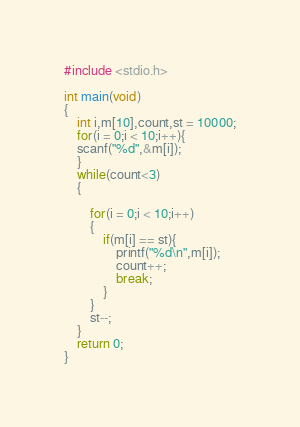<code> <loc_0><loc_0><loc_500><loc_500><_C_>#include <stdio.h>

int main(void)
{
	int i,m[10],count,st = 10000;
	for(i = 0;i < 10;i++){
	scanf("%d",&m[i]);
	}
	while(count<3)
	{
		
		for(i = 0;i < 10;i++)
		{
			if(m[i] == st){
				printf("%d\n",m[i]);
				count++;
				break;
			}
		}
		st--;
	}
	return 0;
}</code> 